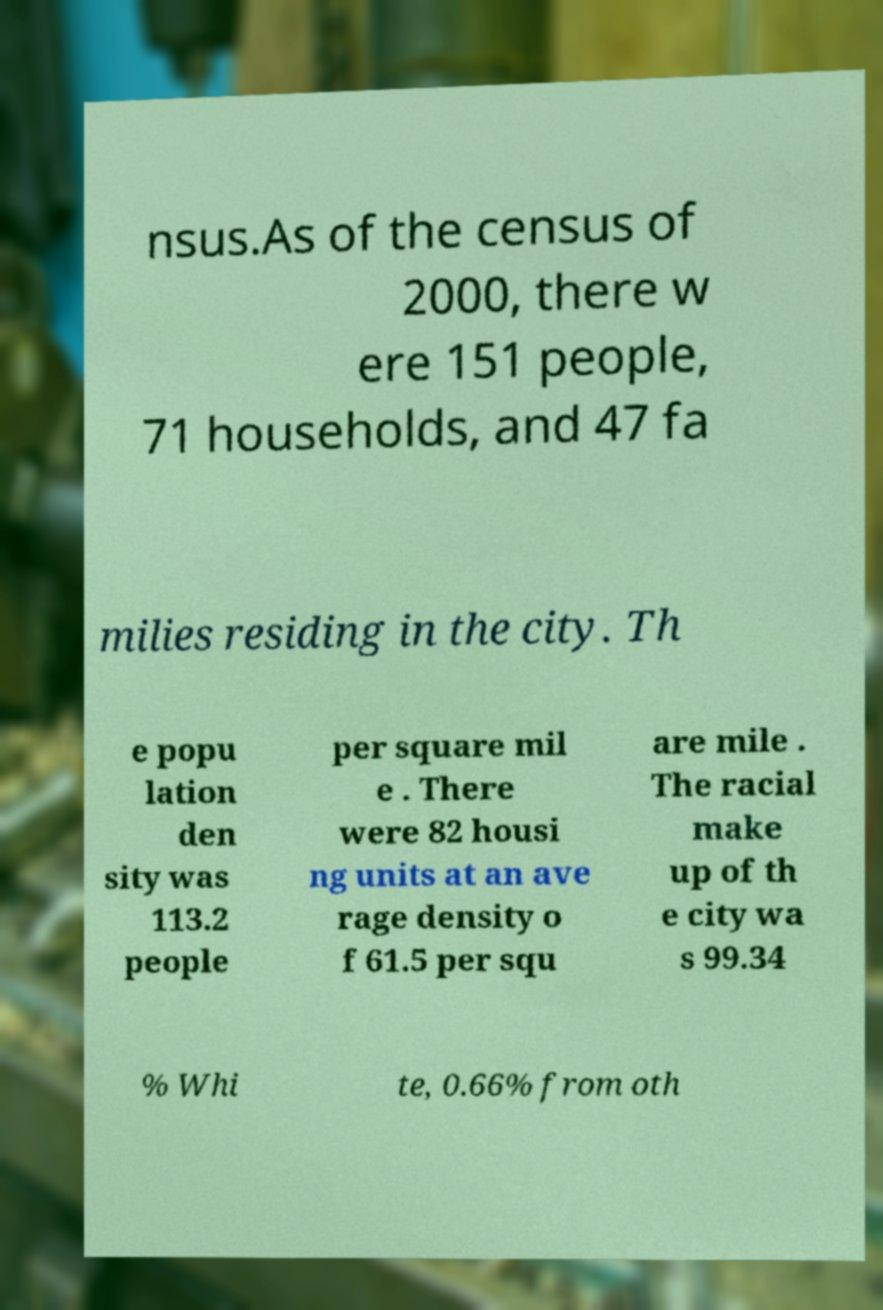There's text embedded in this image that I need extracted. Can you transcribe it verbatim? nsus.As of the census of 2000, there w ere 151 people, 71 households, and 47 fa milies residing in the city. Th e popu lation den sity was 113.2 people per square mil e . There were 82 housi ng units at an ave rage density o f 61.5 per squ are mile . The racial make up of th e city wa s 99.34 % Whi te, 0.66% from oth 